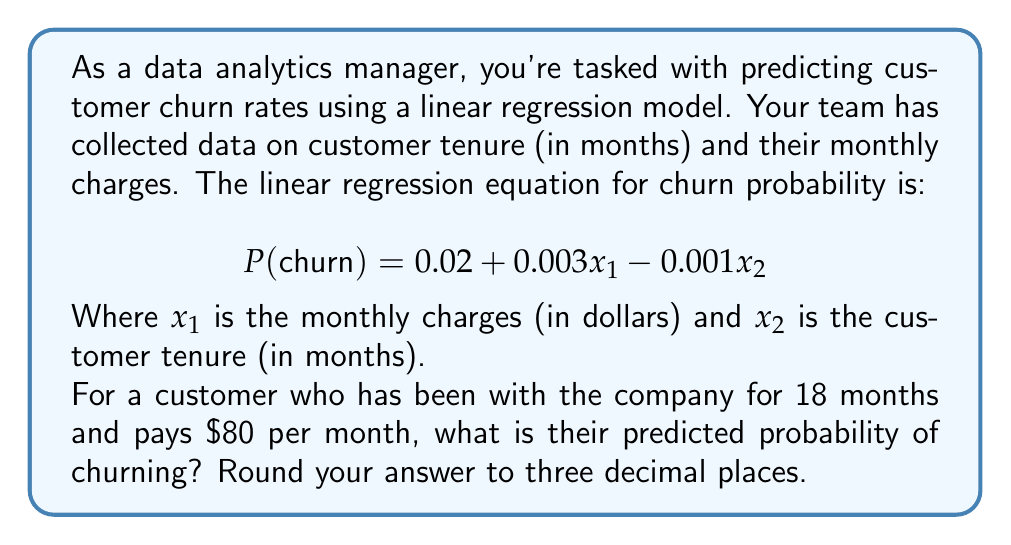Can you answer this question? To solve this problem, we need to follow these steps:

1. Identify the given information:
   - Linear regression equation: $P(\text{churn}) = 0.02 + 0.003x_1 - 0.001x_2$
   - $x_1$ (monthly charges) = $80
   - $x_2$ (customer tenure) = 18 months

2. Substitute the values into the equation:
   $$ P(\text{churn}) = 0.02 + 0.003(80) - 0.001(18) $$

3. Calculate each term:
   - $0.003(80) = 0.24$
   - $0.001(18) = 0.018$

4. Perform the arithmetic:
   $$ P(\text{churn}) = 0.02 + 0.24 - 0.018 $$
   $$ P(\text{churn}) = 0.242 $$

5. Round the result to three decimal places:
   $$ P(\text{churn}) \approx 0.242 $$

Therefore, the predicted probability of churn for this customer is 0.242 or 24.2%.
Answer: 0.242 